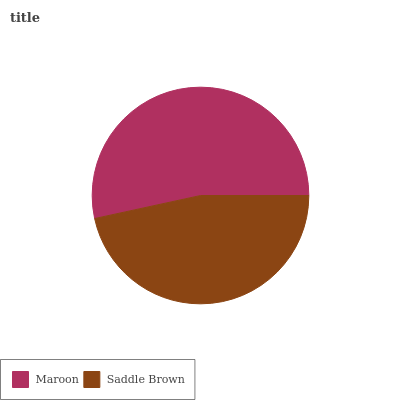Is Saddle Brown the minimum?
Answer yes or no. Yes. Is Maroon the maximum?
Answer yes or no. Yes. Is Saddle Brown the maximum?
Answer yes or no. No. Is Maroon greater than Saddle Brown?
Answer yes or no. Yes. Is Saddle Brown less than Maroon?
Answer yes or no. Yes. Is Saddle Brown greater than Maroon?
Answer yes or no. No. Is Maroon less than Saddle Brown?
Answer yes or no. No. Is Maroon the high median?
Answer yes or no. Yes. Is Saddle Brown the low median?
Answer yes or no. Yes. Is Saddle Brown the high median?
Answer yes or no. No. Is Maroon the low median?
Answer yes or no. No. 